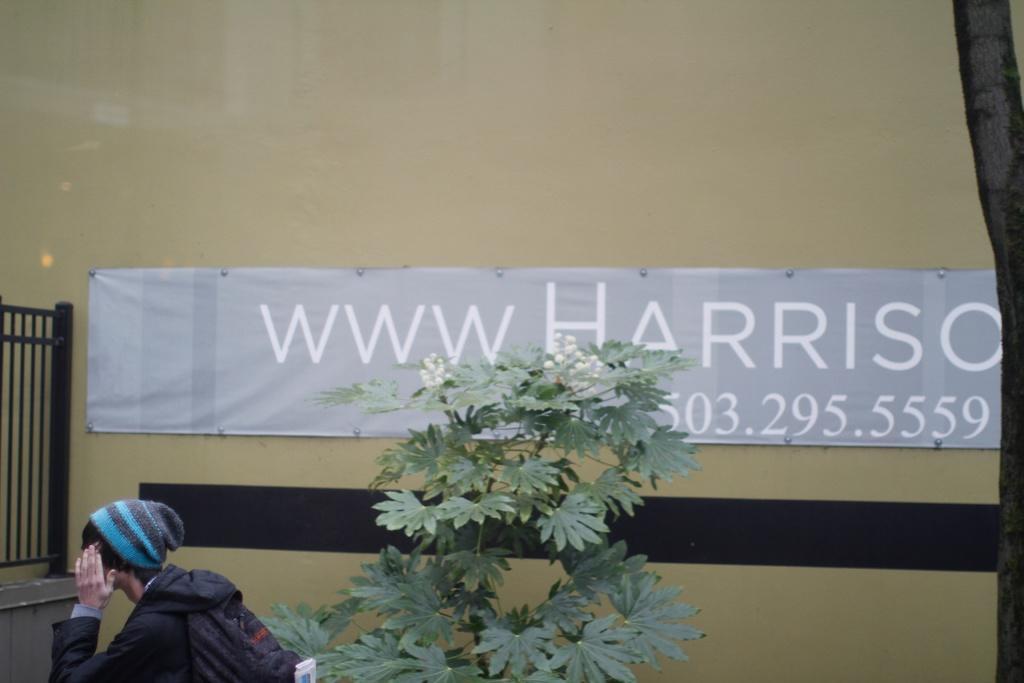How would you summarize this image in a sentence or two? In this image we can see a person and a plant. In the background of the image there is a wall, name board and other objects. 